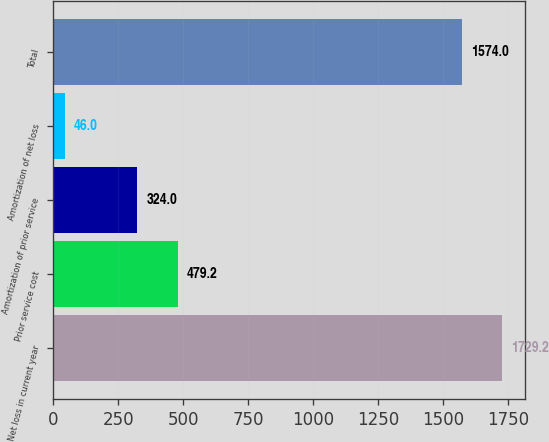Convert chart. <chart><loc_0><loc_0><loc_500><loc_500><bar_chart><fcel>Net loss in current year<fcel>Prior service cost<fcel>Amortization of prior service<fcel>Amortization of net loss<fcel>Total<nl><fcel>1729.2<fcel>479.2<fcel>324<fcel>46<fcel>1574<nl></chart> 